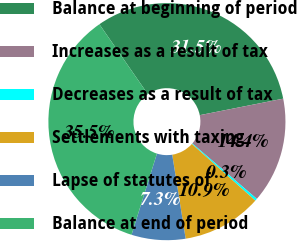Convert chart to OTSL. <chart><loc_0><loc_0><loc_500><loc_500><pie_chart><fcel>Balance at beginning of period<fcel>Increases as a result of tax<fcel>Decreases as a result of tax<fcel>Settlements with taxing<fcel>Lapse of statutes of<fcel>Balance at end of period<nl><fcel>31.54%<fcel>14.4%<fcel>0.31%<fcel>10.87%<fcel>7.35%<fcel>35.53%<nl></chart> 